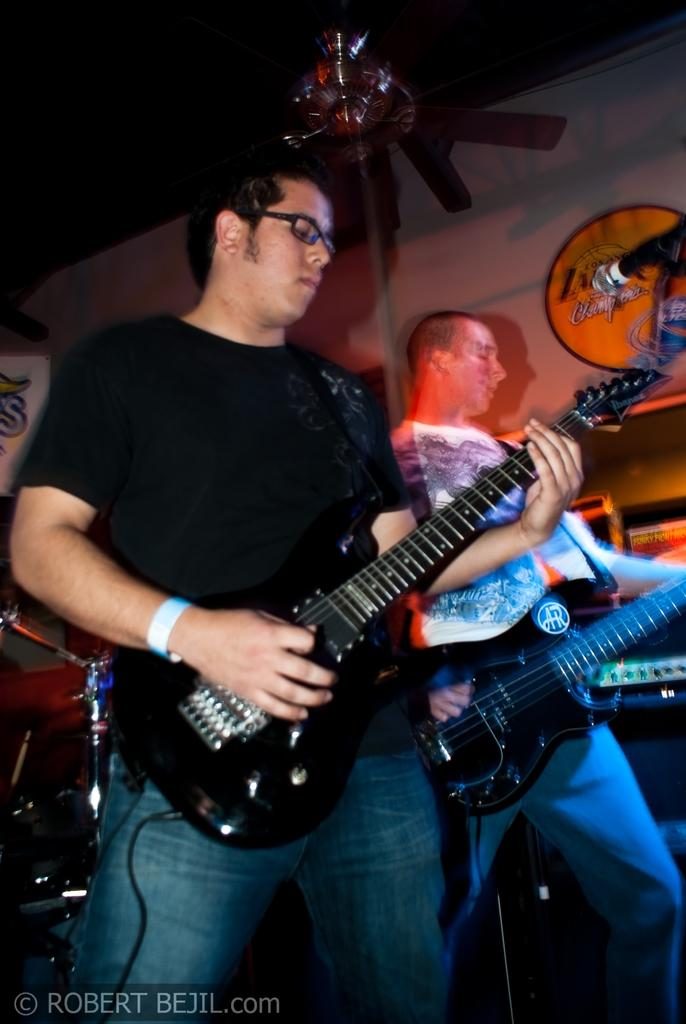How many people are in the image? There are two men in the image. What are the men doing in the image? The men are standing and playing guitars. Can you describe any accessories worn by the men? One of the men is wearing a wristband, and the other man is wearing spectacles. What object is present in the image that is commonly used for amplifying sound? There is a microphone in the image. What type of game are the men playing in the image? There is no game being played in the image; the men are playing guitars. Can you describe the shape of the circle in the image? There is no circle present in the image. 